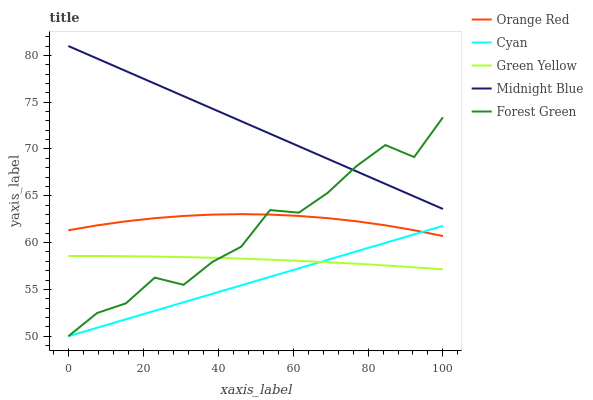Does Cyan have the minimum area under the curve?
Answer yes or no. Yes. Does Midnight Blue have the maximum area under the curve?
Answer yes or no. Yes. Does Forest Green have the minimum area under the curve?
Answer yes or no. No. Does Forest Green have the maximum area under the curve?
Answer yes or no. No. Is Cyan the smoothest?
Answer yes or no. Yes. Is Forest Green the roughest?
Answer yes or no. Yes. Is Green Yellow the smoothest?
Answer yes or no. No. Is Green Yellow the roughest?
Answer yes or no. No. Does Cyan have the lowest value?
Answer yes or no. Yes. Does Green Yellow have the lowest value?
Answer yes or no. No. Does Midnight Blue have the highest value?
Answer yes or no. Yes. Does Forest Green have the highest value?
Answer yes or no. No. Is Orange Red less than Midnight Blue?
Answer yes or no. Yes. Is Midnight Blue greater than Green Yellow?
Answer yes or no. Yes. Does Orange Red intersect Forest Green?
Answer yes or no. Yes. Is Orange Red less than Forest Green?
Answer yes or no. No. Is Orange Red greater than Forest Green?
Answer yes or no. No. Does Orange Red intersect Midnight Blue?
Answer yes or no. No. 